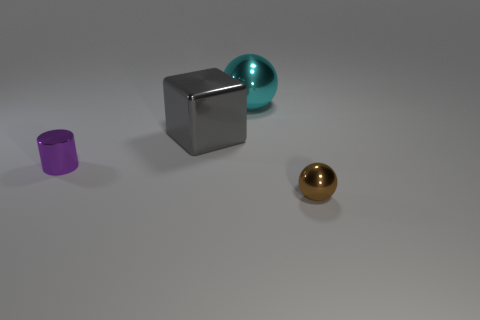Subtract all cylinders. How many objects are left? 3 Add 3 balls. How many objects exist? 7 Subtract all green spheres. Subtract all yellow cylinders. How many spheres are left? 2 Subtract all red cylinders. How many blue balls are left? 0 Subtract all purple matte cylinders. Subtract all large gray objects. How many objects are left? 3 Add 3 blocks. How many blocks are left? 4 Add 3 big brown metallic objects. How many big brown metallic objects exist? 3 Subtract 0 brown cylinders. How many objects are left? 4 Subtract 1 cubes. How many cubes are left? 0 